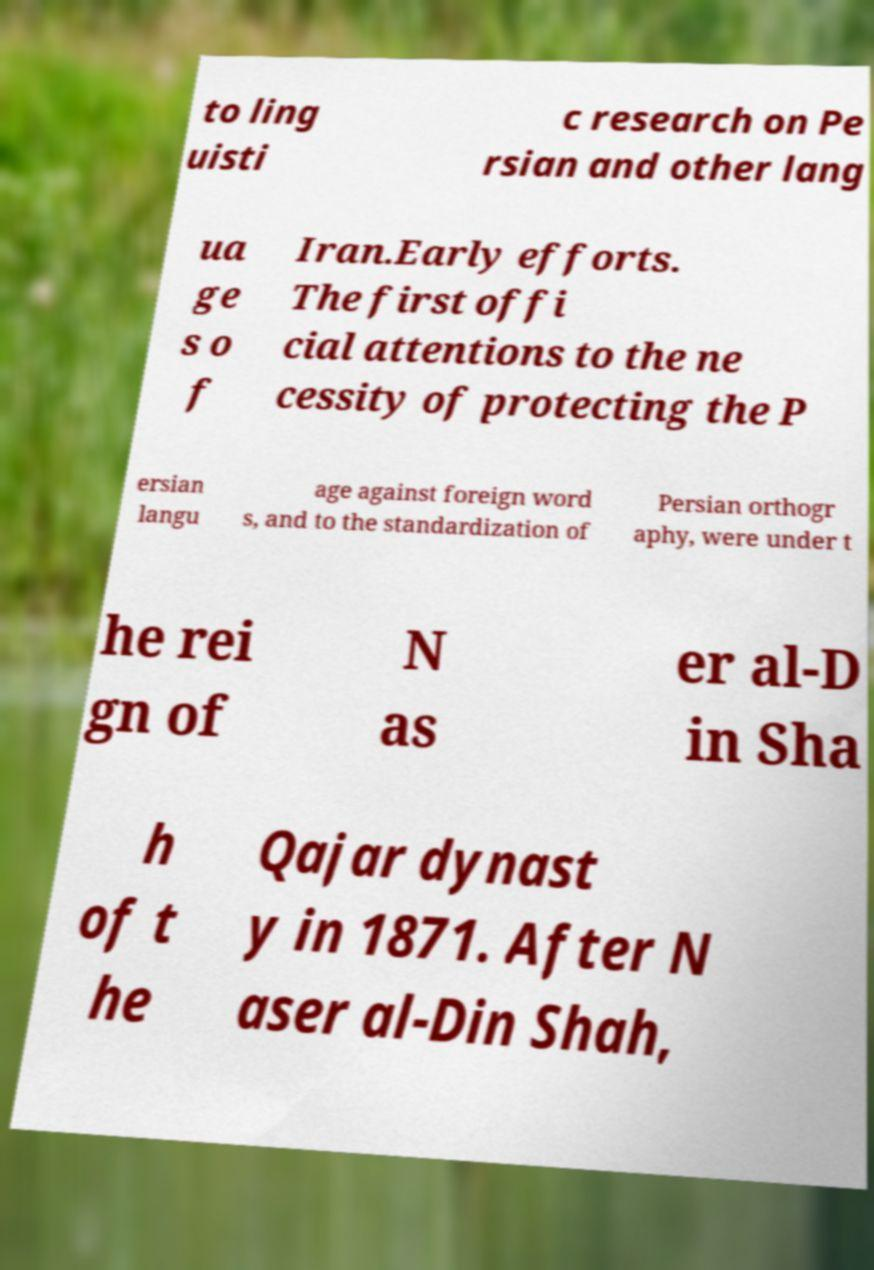There's text embedded in this image that I need extracted. Can you transcribe it verbatim? to ling uisti c research on Pe rsian and other lang ua ge s o f Iran.Early efforts. The first offi cial attentions to the ne cessity of protecting the P ersian langu age against foreign word s, and to the standardization of Persian orthogr aphy, were under t he rei gn of N as er al-D in Sha h of t he Qajar dynast y in 1871. After N aser al-Din Shah, 